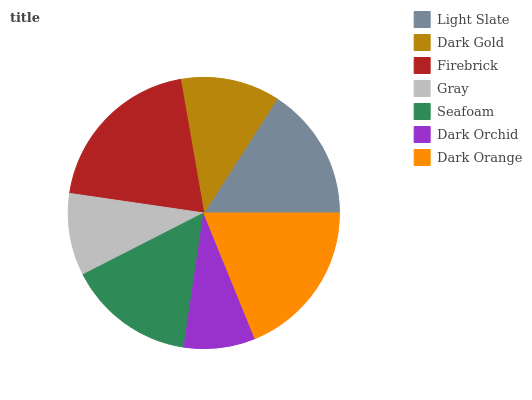Is Dark Orchid the minimum?
Answer yes or no. Yes. Is Firebrick the maximum?
Answer yes or no. Yes. Is Dark Gold the minimum?
Answer yes or no. No. Is Dark Gold the maximum?
Answer yes or no. No. Is Light Slate greater than Dark Gold?
Answer yes or no. Yes. Is Dark Gold less than Light Slate?
Answer yes or no. Yes. Is Dark Gold greater than Light Slate?
Answer yes or no. No. Is Light Slate less than Dark Gold?
Answer yes or no. No. Is Seafoam the high median?
Answer yes or no. Yes. Is Seafoam the low median?
Answer yes or no. Yes. Is Firebrick the high median?
Answer yes or no. No. Is Dark Orchid the low median?
Answer yes or no. No. 